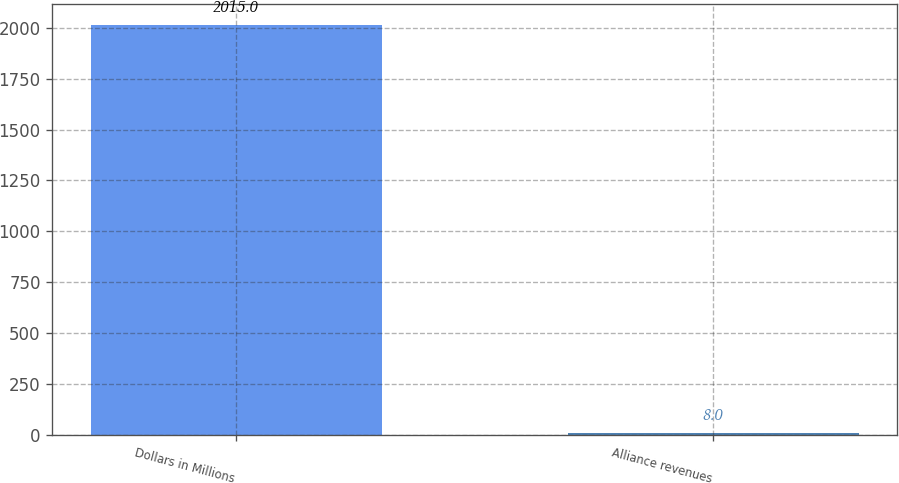Convert chart to OTSL. <chart><loc_0><loc_0><loc_500><loc_500><bar_chart><fcel>Dollars in Millions<fcel>Alliance revenues<nl><fcel>2015<fcel>8<nl></chart> 